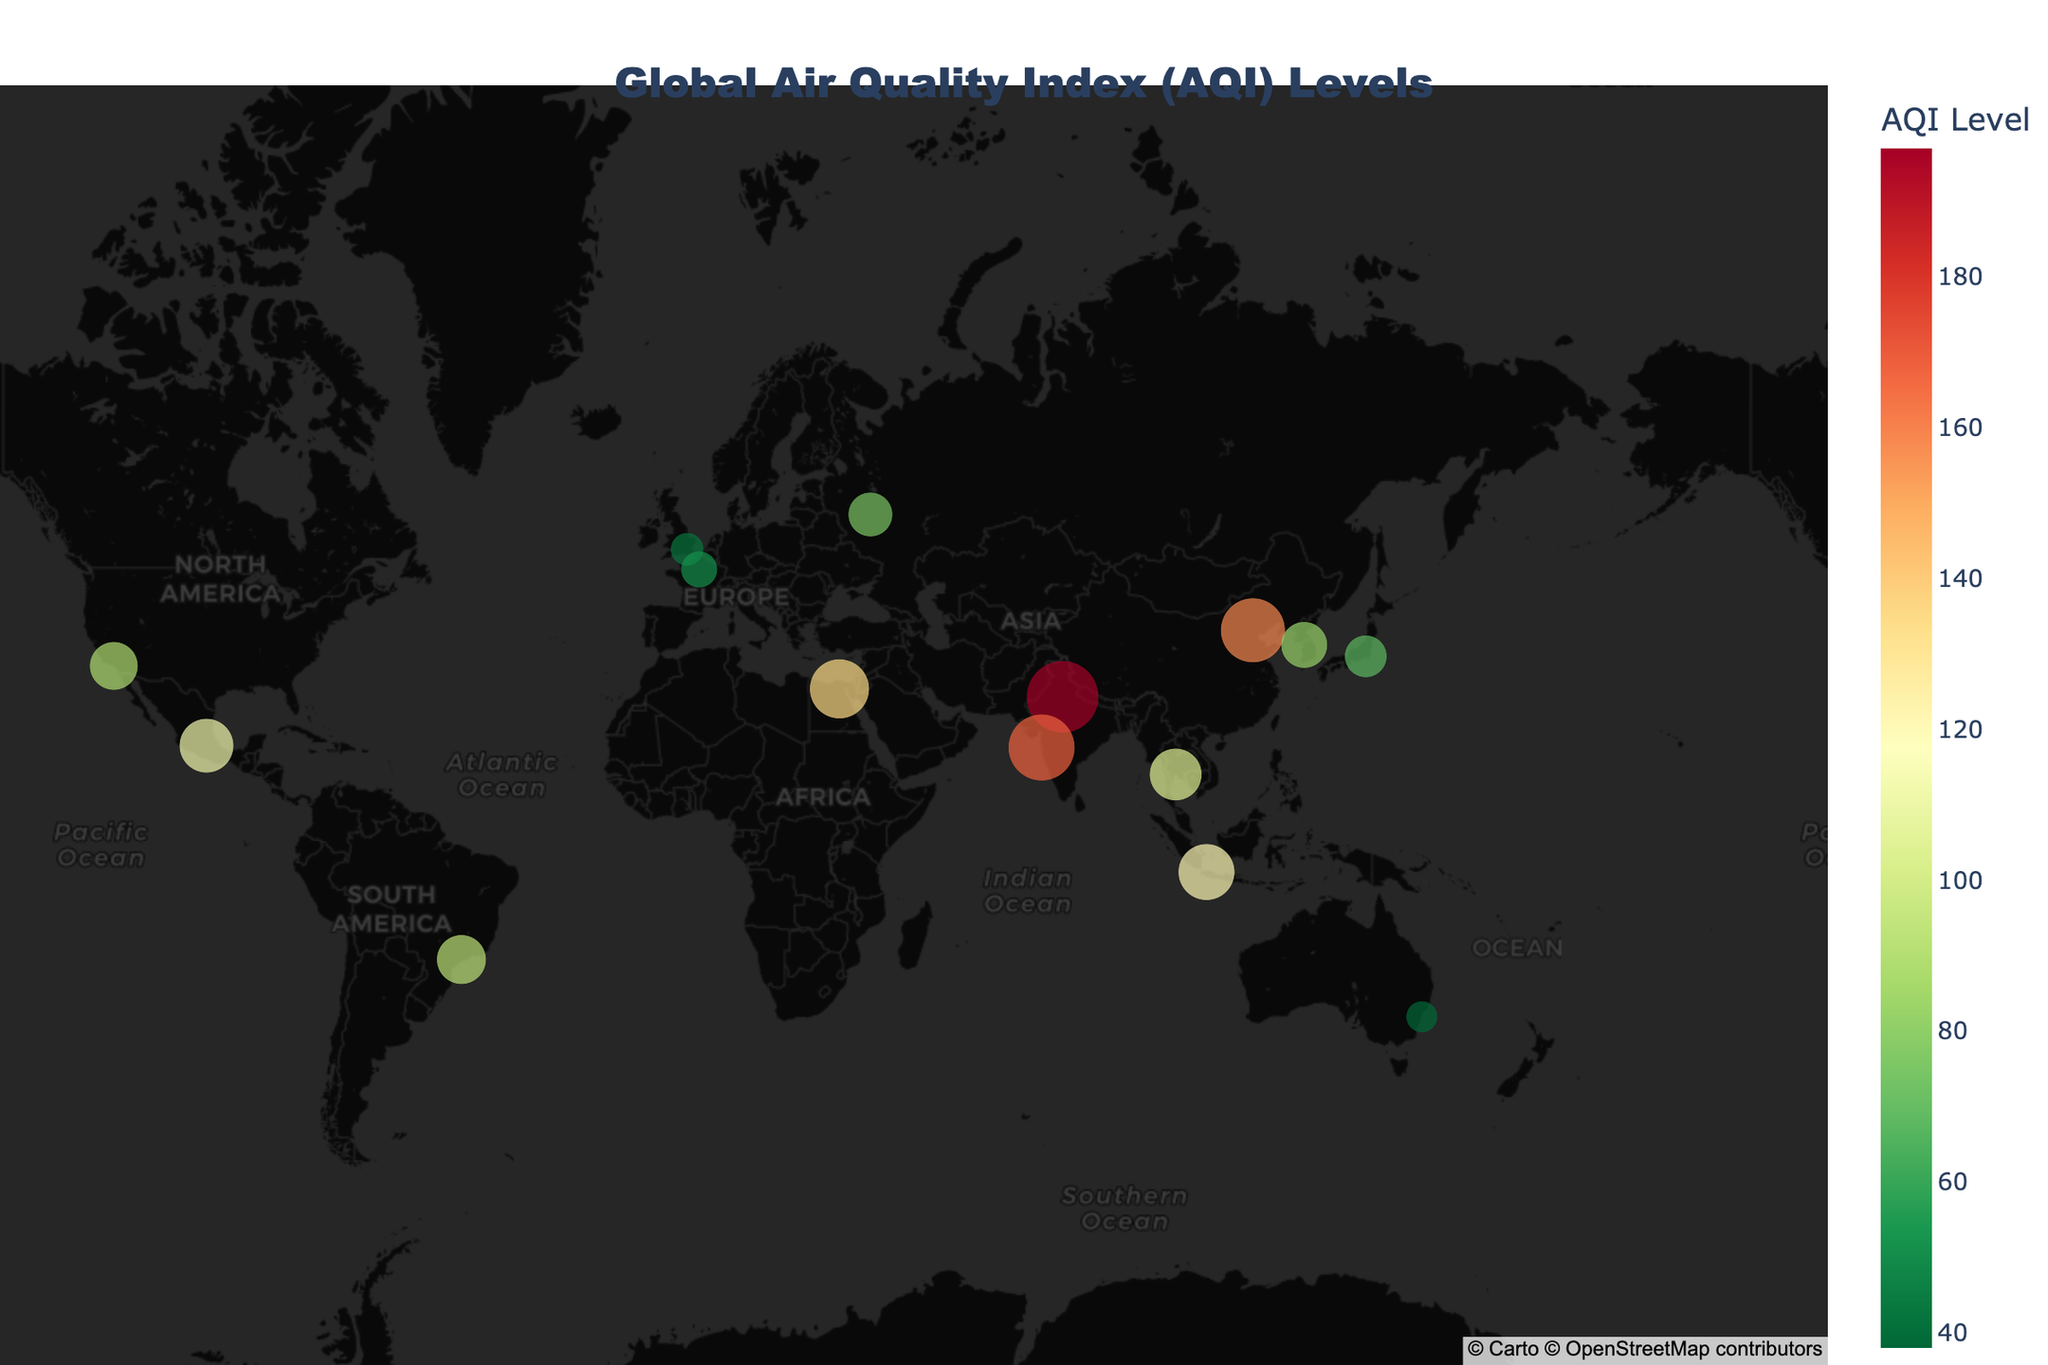What is the title of the map? The title of the map is prominently displayed at the top of the figure in large font, indicating the main subject of the plotted data.
Answer: Global Air Quality Index (AQI) Levels Which city has the highest AQI level? By looking at the map and hovering over the cities, the AQI values are displayed; the highest value is 197 for New Delhi, India.
Answer: New Delhi Which city in the USA is represented on the map, and what is its AQI level? On the map, Los Angeles is the city located in the USA; hovering over it reveals its AQI level of 89.
Answer: Los Angeles, 89 How many cities in Asia are displayed on the map? The map shows cities in various regions; counting those in Asia includes Beijing, New Delhi, Tokyo, Bangkok, Jakarta, Seoul, and Mumbai, totaling 7 cities.
Answer: 7 What is the difference in AQI levels between Tokyo and Jakarta? The AQI level of Tokyo is 68, and Jakarta's is 121. The difference is calculated by subtracting the lower AQI from the higher one: 121 - 68.
Answer: 53 Which city has a better air quality index, Paris or London? Hovering over the points for Paris and London on the map shows their AQI levels. Paris has an AQI of 51, and London has an AQI of 42; a lower AQI indicates better air quality.
Answer: London What is the median AQI value of all the cities shown on the map? To calculate the median AQI, list all AQI values in ascending order and find the middle one. The values are 38, 42, 51, 68, 75, 82, 89, 93, 104, 112, 121, 135, 158, 168, 197. The median, being the middle value of this ordered list, is 89.
Answer: 89 Which hemisphere has more cities with AQI data points, the Northern or Southern? From the plotted cities, count those located in the Northern Hemisphere (Beijing, New Delhi, Los Angeles, London, Mexico City, Cairo, Paris, Tokyo, Moscow, Seoul, Mumbai) and the Southern Hemisphere (São Paulo, Sydney, Jakarta). The Northern Hemisphere has more cities.
Answer: Northern Hemisphere What is the average AQI level of the cities in the Southern Hemisphere? The AQI levels for the Southern Hemisphere cities are São Paulo (93), Sydney (38), and Jakarta (121). Sum these values: 93 + 38 + 121 = 252. Then, divide by the number of cities (3).
Answer: 84 How does the AQI level of Cairo compare to that of Mexico City? Find the AQI levels of Cairo (135) and Mexico City (112) by hovering over the respective city points. Cairo has a higher AQI level than Mexico City.
Answer: Cairo has a higher AQI Which city in Europe has the lowest AQI level, and what is it? The cities in Europe on the map are London, Paris, and Moscow. By comparing their AQI levels (London: 42, Paris: 51, Moscow: 75), London has the lowest AQI.
Answer: London, 42 